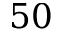<formula> <loc_0><loc_0><loc_500><loc_500>5 0</formula> 